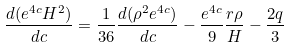<formula> <loc_0><loc_0><loc_500><loc_500>\frac { d ( e ^ { 4 c } H ^ { 2 } ) } { d c } = \frac { 1 } { 3 6 } \frac { d ( \rho ^ { 2 } e ^ { 4 c } ) } { d c } - \frac { e ^ { 4 c } } { 9 } \frac { r \rho } { H } - \frac { 2 q } { 3 }</formula> 